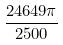Convert formula to latex. <formula><loc_0><loc_0><loc_500><loc_500>\frac { 2 4 6 4 9 \pi } { 2 5 0 0 }</formula> 